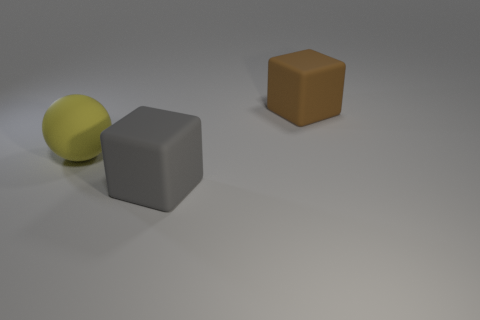Add 1 big gray matte things. How many objects exist? 4 Subtract all blocks. How many objects are left? 1 Subtract all brown matte objects. Subtract all large yellow objects. How many objects are left? 1 Add 1 yellow rubber spheres. How many yellow rubber spheres are left? 2 Add 1 tiny cyan metal cylinders. How many tiny cyan metal cylinders exist? 1 Subtract 0 purple blocks. How many objects are left? 3 